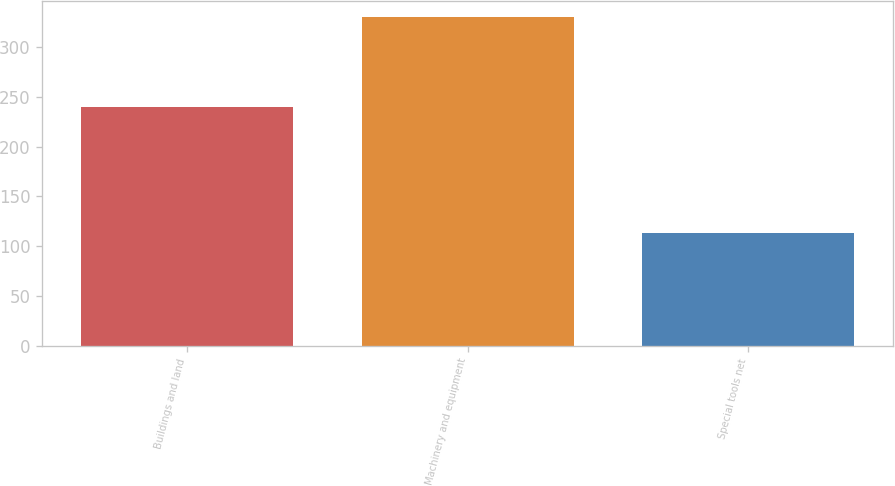Convert chart to OTSL. <chart><loc_0><loc_0><loc_500><loc_500><bar_chart><fcel>Buildings and land<fcel>Machinery and equipment<fcel>Special tools net<nl><fcel>240<fcel>330<fcel>113<nl></chart> 